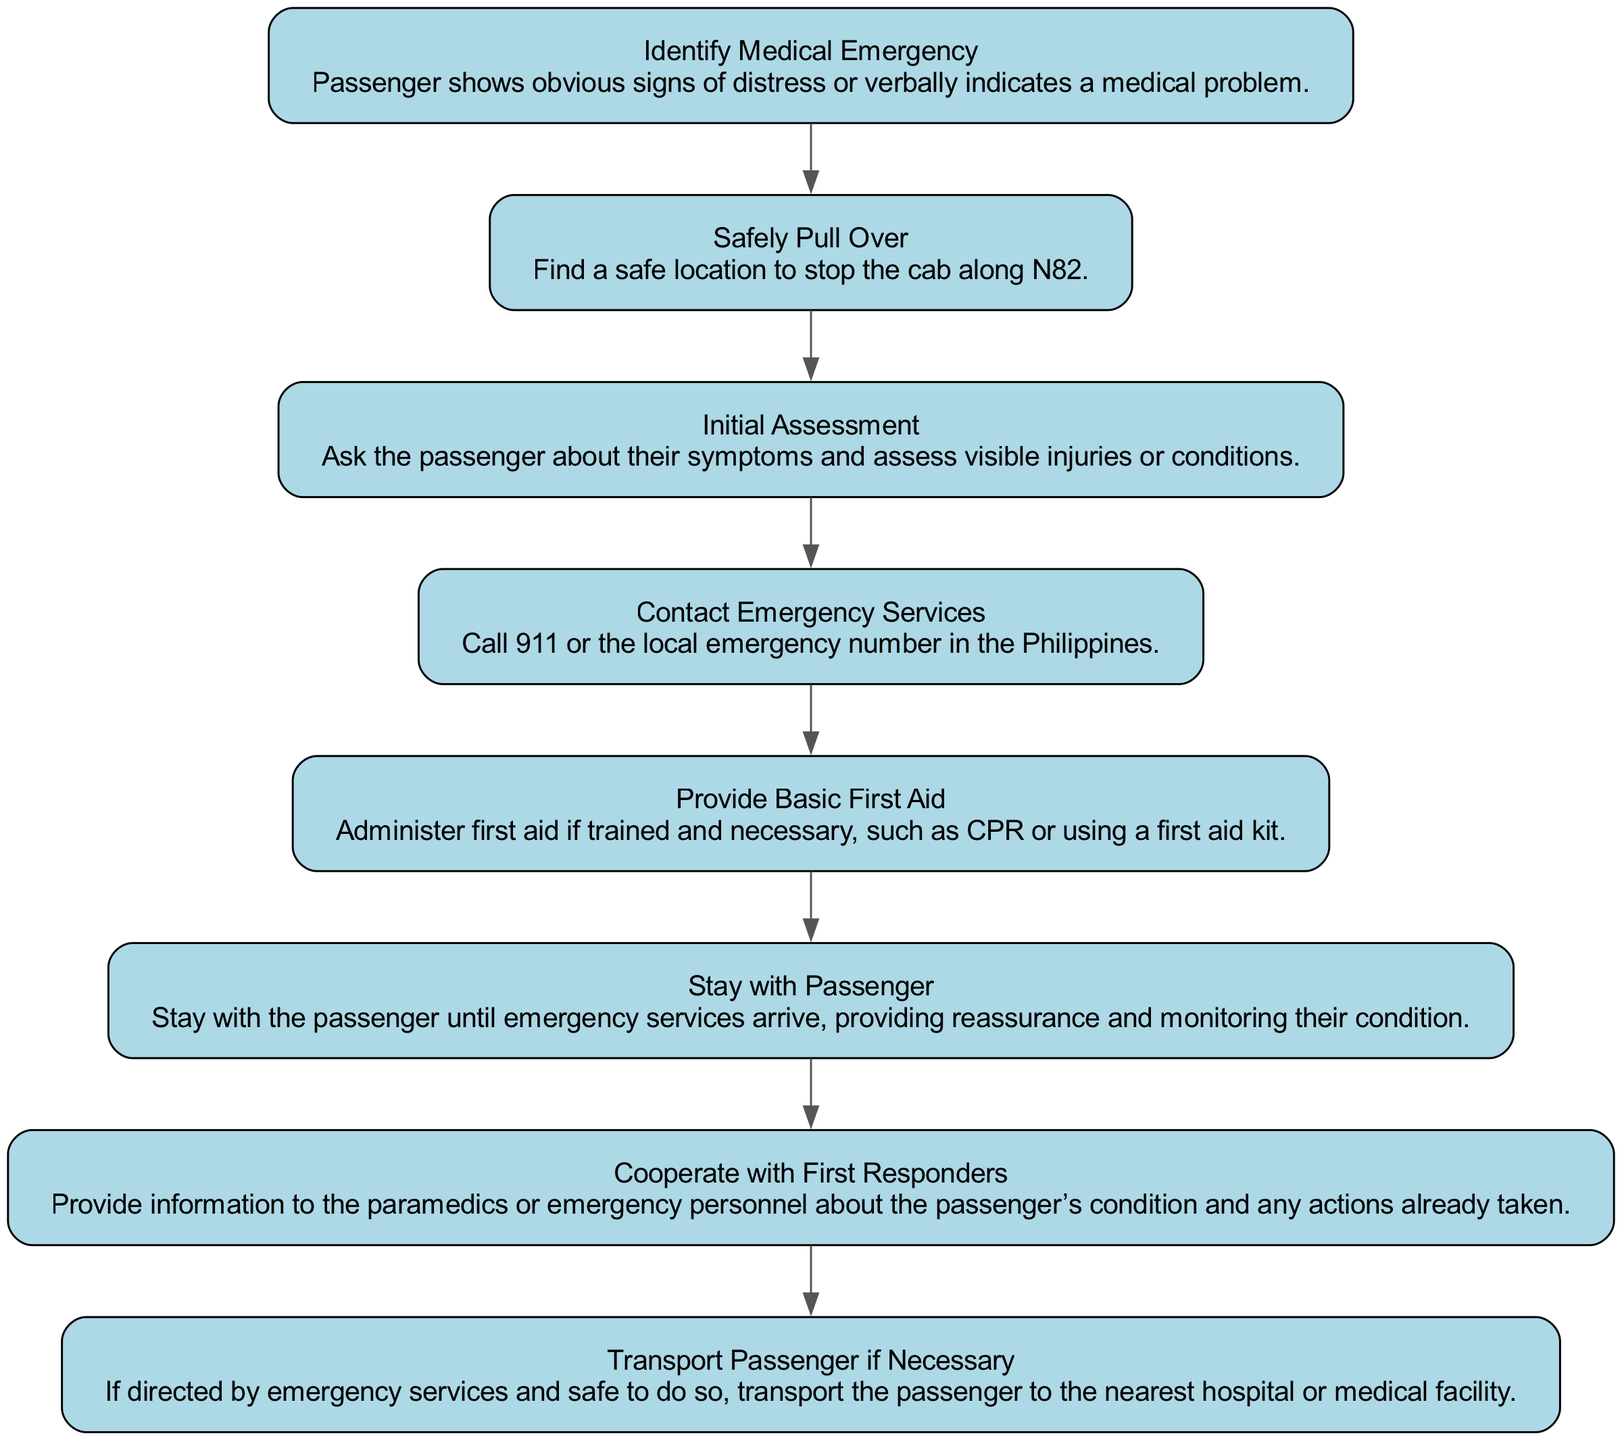What is the first action to take in a medical emergency? The diagram indicates that the first action is to "Identify Medical Emergency," which involves recognizing signs of distress or hearing the passenger's indication of a medical issue.
Answer: Identify Medical Emergency How many nodes are in the diagram? The diagram contains eight elements, which are represented as nodes in the pathway.
Answer: 8 What action follows after "Safely Pull Over"? After the action of "Safely Pull Over," the next step is "Initial Assessment," where the driver's role is to ask the passenger about symptoms and assess visible injuries.
Answer: Initial Assessment Which step involves providing information to paramedics? The step that involves providing information to paramedics is "Cooperate with First Responders," where the driver shares details about the passenger's condition and previous actions taken.
Answer: Cooperate with First Responders What is the last action in the pathway? The last action in the pathway is "Transport Passenger if Necessary," which occurs if emergency services direct the driver and it is safe to do so.
Answer: Transport Passenger if Necessary What should you do after contacting emergency services? After contacting emergency services, the next action is to "Stay with Passenger," ensuring continuous support until help arrives while monitoring the passenger.
Answer: Stay with Passenger How many steps require the driver to provide assistance or action themselves? There are three steps where the driver is required to provide assistance or take action themselves: "Provide Basic First Aid," "Stay with Passenger," and "Safely Pull Over."
Answer: 3 What is the role of the initial assessment? The role of the initial assessment is to gather information about the passenger's symptoms and evaluate any visible injuries, which is essential for determining the right course of action.
Answer: Ask the passenger about their symptoms and assess visible injuries or conditions 